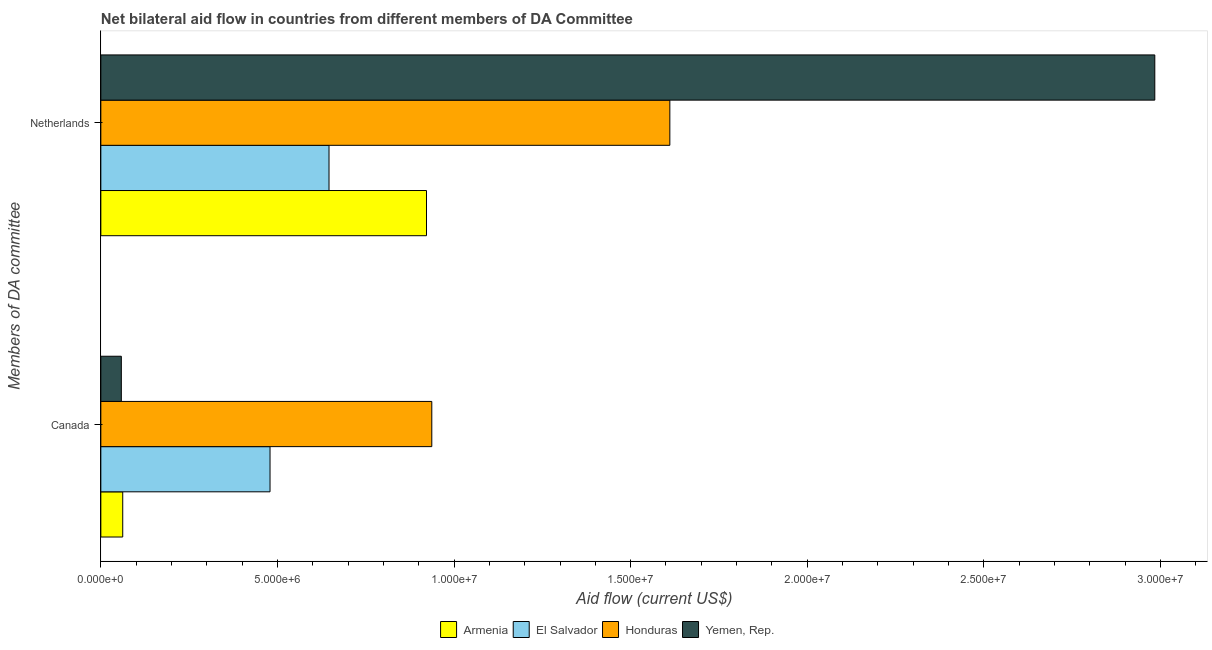How many different coloured bars are there?
Provide a succinct answer. 4. How many groups of bars are there?
Make the answer very short. 2. Are the number of bars on each tick of the Y-axis equal?
Keep it short and to the point. Yes. How many bars are there on the 1st tick from the bottom?
Offer a terse response. 4. What is the amount of aid given by canada in Armenia?
Ensure brevity in your answer.  6.20e+05. Across all countries, what is the maximum amount of aid given by canada?
Your answer should be compact. 9.37e+06. Across all countries, what is the minimum amount of aid given by netherlands?
Provide a short and direct response. 6.46e+06. In which country was the amount of aid given by canada maximum?
Your response must be concise. Honduras. In which country was the amount of aid given by canada minimum?
Your answer should be compact. Yemen, Rep. What is the total amount of aid given by canada in the graph?
Offer a terse response. 1.54e+07. What is the difference between the amount of aid given by canada in El Salvador and that in Honduras?
Your answer should be compact. -4.58e+06. What is the difference between the amount of aid given by canada in Honduras and the amount of aid given by netherlands in El Salvador?
Provide a succinct answer. 2.91e+06. What is the average amount of aid given by canada per country?
Offer a terse response. 3.84e+06. What is the difference between the amount of aid given by netherlands and amount of aid given by canada in El Salvador?
Your answer should be compact. 1.67e+06. What is the ratio of the amount of aid given by netherlands in Armenia to that in Honduras?
Ensure brevity in your answer.  0.57. What does the 3rd bar from the top in Canada represents?
Ensure brevity in your answer.  El Salvador. What does the 2nd bar from the bottom in Netherlands represents?
Offer a very short reply. El Salvador. How many bars are there?
Your answer should be compact. 8. Are all the bars in the graph horizontal?
Provide a succinct answer. Yes. Are the values on the major ticks of X-axis written in scientific E-notation?
Ensure brevity in your answer.  Yes. Does the graph contain grids?
Your response must be concise. No. Where does the legend appear in the graph?
Ensure brevity in your answer.  Bottom center. What is the title of the graph?
Give a very brief answer. Net bilateral aid flow in countries from different members of DA Committee. What is the label or title of the Y-axis?
Your answer should be very brief. Members of DA committee. What is the Aid flow (current US$) of Armenia in Canada?
Provide a short and direct response. 6.20e+05. What is the Aid flow (current US$) in El Salvador in Canada?
Your answer should be very brief. 4.79e+06. What is the Aid flow (current US$) of Honduras in Canada?
Give a very brief answer. 9.37e+06. What is the Aid flow (current US$) in Yemen, Rep. in Canada?
Ensure brevity in your answer.  5.80e+05. What is the Aid flow (current US$) of Armenia in Netherlands?
Provide a succinct answer. 9.22e+06. What is the Aid flow (current US$) of El Salvador in Netherlands?
Offer a very short reply. 6.46e+06. What is the Aid flow (current US$) in Honduras in Netherlands?
Offer a very short reply. 1.61e+07. What is the Aid flow (current US$) of Yemen, Rep. in Netherlands?
Your answer should be compact. 2.98e+07. Across all Members of DA committee, what is the maximum Aid flow (current US$) of Armenia?
Keep it short and to the point. 9.22e+06. Across all Members of DA committee, what is the maximum Aid flow (current US$) of El Salvador?
Your response must be concise. 6.46e+06. Across all Members of DA committee, what is the maximum Aid flow (current US$) in Honduras?
Make the answer very short. 1.61e+07. Across all Members of DA committee, what is the maximum Aid flow (current US$) of Yemen, Rep.?
Keep it short and to the point. 2.98e+07. Across all Members of DA committee, what is the minimum Aid flow (current US$) of Armenia?
Give a very brief answer. 6.20e+05. Across all Members of DA committee, what is the minimum Aid flow (current US$) in El Salvador?
Keep it short and to the point. 4.79e+06. Across all Members of DA committee, what is the minimum Aid flow (current US$) of Honduras?
Make the answer very short. 9.37e+06. Across all Members of DA committee, what is the minimum Aid flow (current US$) in Yemen, Rep.?
Offer a very short reply. 5.80e+05. What is the total Aid flow (current US$) of Armenia in the graph?
Offer a very short reply. 9.84e+06. What is the total Aid flow (current US$) of El Salvador in the graph?
Give a very brief answer. 1.12e+07. What is the total Aid flow (current US$) in Honduras in the graph?
Give a very brief answer. 2.55e+07. What is the total Aid flow (current US$) in Yemen, Rep. in the graph?
Keep it short and to the point. 3.04e+07. What is the difference between the Aid flow (current US$) in Armenia in Canada and that in Netherlands?
Offer a terse response. -8.60e+06. What is the difference between the Aid flow (current US$) in El Salvador in Canada and that in Netherlands?
Give a very brief answer. -1.67e+06. What is the difference between the Aid flow (current US$) in Honduras in Canada and that in Netherlands?
Your response must be concise. -6.74e+06. What is the difference between the Aid flow (current US$) of Yemen, Rep. in Canada and that in Netherlands?
Provide a succinct answer. -2.93e+07. What is the difference between the Aid flow (current US$) of Armenia in Canada and the Aid flow (current US$) of El Salvador in Netherlands?
Ensure brevity in your answer.  -5.84e+06. What is the difference between the Aid flow (current US$) of Armenia in Canada and the Aid flow (current US$) of Honduras in Netherlands?
Provide a short and direct response. -1.55e+07. What is the difference between the Aid flow (current US$) in Armenia in Canada and the Aid flow (current US$) in Yemen, Rep. in Netherlands?
Your answer should be compact. -2.92e+07. What is the difference between the Aid flow (current US$) in El Salvador in Canada and the Aid flow (current US$) in Honduras in Netherlands?
Offer a very short reply. -1.13e+07. What is the difference between the Aid flow (current US$) in El Salvador in Canada and the Aid flow (current US$) in Yemen, Rep. in Netherlands?
Offer a very short reply. -2.50e+07. What is the difference between the Aid flow (current US$) in Honduras in Canada and the Aid flow (current US$) in Yemen, Rep. in Netherlands?
Offer a very short reply. -2.05e+07. What is the average Aid flow (current US$) of Armenia per Members of DA committee?
Provide a short and direct response. 4.92e+06. What is the average Aid flow (current US$) of El Salvador per Members of DA committee?
Your answer should be very brief. 5.62e+06. What is the average Aid flow (current US$) of Honduras per Members of DA committee?
Ensure brevity in your answer.  1.27e+07. What is the average Aid flow (current US$) in Yemen, Rep. per Members of DA committee?
Make the answer very short. 1.52e+07. What is the difference between the Aid flow (current US$) of Armenia and Aid flow (current US$) of El Salvador in Canada?
Ensure brevity in your answer.  -4.17e+06. What is the difference between the Aid flow (current US$) of Armenia and Aid flow (current US$) of Honduras in Canada?
Make the answer very short. -8.75e+06. What is the difference between the Aid flow (current US$) in Armenia and Aid flow (current US$) in Yemen, Rep. in Canada?
Offer a terse response. 4.00e+04. What is the difference between the Aid flow (current US$) of El Salvador and Aid flow (current US$) of Honduras in Canada?
Your response must be concise. -4.58e+06. What is the difference between the Aid flow (current US$) in El Salvador and Aid flow (current US$) in Yemen, Rep. in Canada?
Your response must be concise. 4.21e+06. What is the difference between the Aid flow (current US$) in Honduras and Aid flow (current US$) in Yemen, Rep. in Canada?
Offer a very short reply. 8.79e+06. What is the difference between the Aid flow (current US$) of Armenia and Aid flow (current US$) of El Salvador in Netherlands?
Your answer should be compact. 2.76e+06. What is the difference between the Aid flow (current US$) in Armenia and Aid flow (current US$) in Honduras in Netherlands?
Your answer should be very brief. -6.89e+06. What is the difference between the Aid flow (current US$) of Armenia and Aid flow (current US$) of Yemen, Rep. in Netherlands?
Make the answer very short. -2.06e+07. What is the difference between the Aid flow (current US$) in El Salvador and Aid flow (current US$) in Honduras in Netherlands?
Provide a short and direct response. -9.65e+06. What is the difference between the Aid flow (current US$) of El Salvador and Aid flow (current US$) of Yemen, Rep. in Netherlands?
Keep it short and to the point. -2.34e+07. What is the difference between the Aid flow (current US$) of Honduras and Aid flow (current US$) of Yemen, Rep. in Netherlands?
Offer a terse response. -1.37e+07. What is the ratio of the Aid flow (current US$) of Armenia in Canada to that in Netherlands?
Ensure brevity in your answer.  0.07. What is the ratio of the Aid flow (current US$) of El Salvador in Canada to that in Netherlands?
Offer a very short reply. 0.74. What is the ratio of the Aid flow (current US$) in Honduras in Canada to that in Netherlands?
Keep it short and to the point. 0.58. What is the ratio of the Aid flow (current US$) of Yemen, Rep. in Canada to that in Netherlands?
Ensure brevity in your answer.  0.02. What is the difference between the highest and the second highest Aid flow (current US$) of Armenia?
Your response must be concise. 8.60e+06. What is the difference between the highest and the second highest Aid flow (current US$) in El Salvador?
Keep it short and to the point. 1.67e+06. What is the difference between the highest and the second highest Aid flow (current US$) in Honduras?
Offer a terse response. 6.74e+06. What is the difference between the highest and the second highest Aid flow (current US$) of Yemen, Rep.?
Offer a terse response. 2.93e+07. What is the difference between the highest and the lowest Aid flow (current US$) in Armenia?
Offer a very short reply. 8.60e+06. What is the difference between the highest and the lowest Aid flow (current US$) in El Salvador?
Your answer should be compact. 1.67e+06. What is the difference between the highest and the lowest Aid flow (current US$) of Honduras?
Give a very brief answer. 6.74e+06. What is the difference between the highest and the lowest Aid flow (current US$) in Yemen, Rep.?
Your answer should be compact. 2.93e+07. 